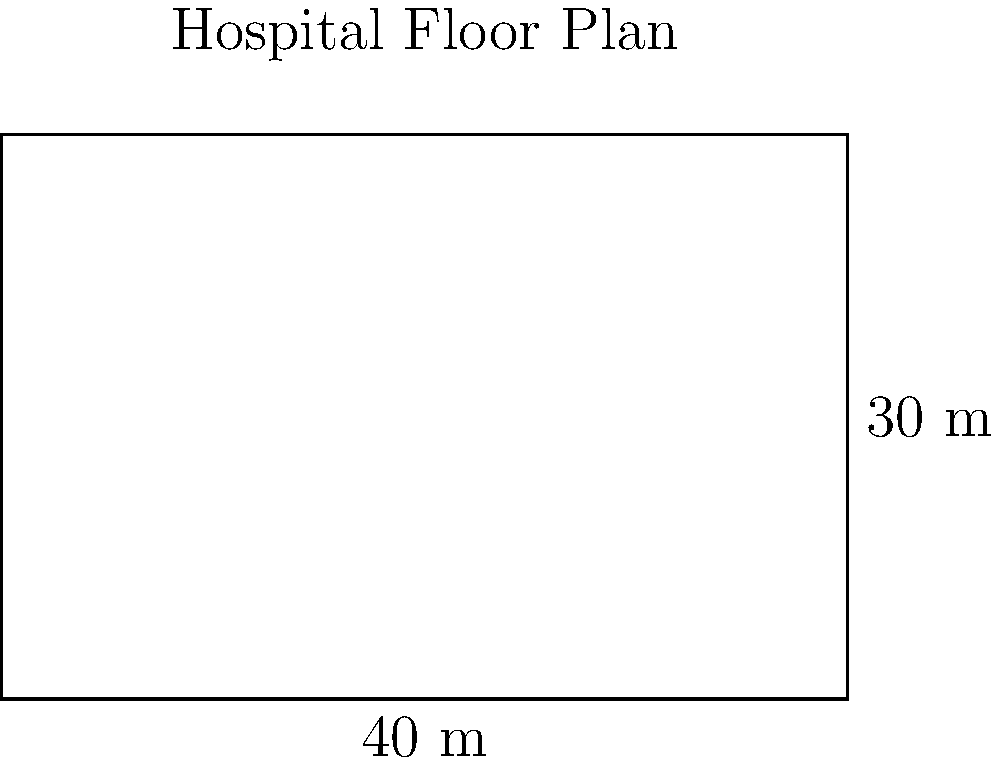As part of a healthcare reform initiative, you're assessing the capacity of a new hospital. The rectangular floor plan of the main ward is shown above. If each patient requires a minimum of 100 square meters of floor space, what is the maximum number of patients that can be accommodated in this ward? To solve this problem, we need to follow these steps:

1) Calculate the area of the rectangular floor plan:
   - The length of the rectangle is 40 m
   - The width of the rectangle is 30 m
   - Area formula: $A = l \times w$
   - $A = 40 \text{ m} \times 30 \text{ m} = 1200 \text{ m}^2$

2) Determine the number of patients that can be accommodated:
   - Each patient requires 100 square meters
   - Number of patients = Total area ÷ Area per patient
   - $\text{Number of patients} = \frac{1200 \text{ m}^2}{100 \text{ m}^2/\text{patient}} = 12 \text{ patients}$

3) Since we can't have a fraction of a patient, we round down to the nearest whole number.

Therefore, the maximum number of patients that can be accommodated in this ward is 12.
Answer: 12 patients 